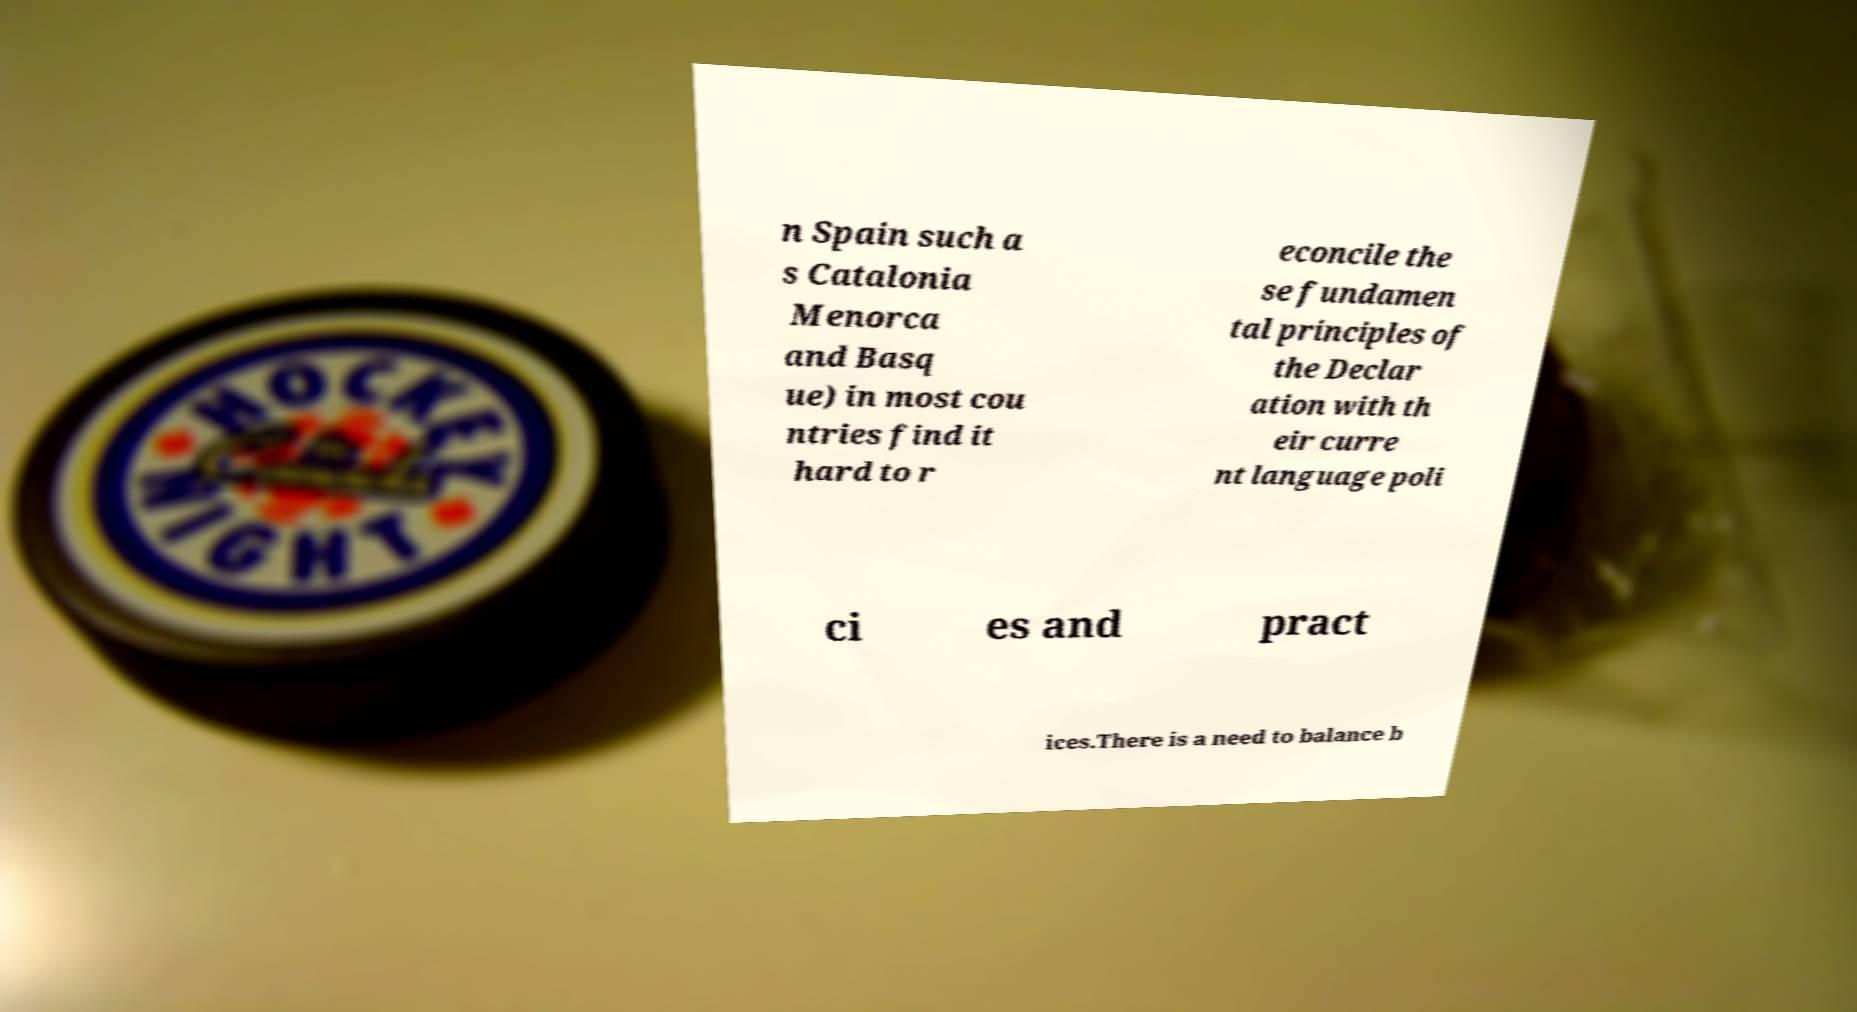Please read and relay the text visible in this image. What does it say? n Spain such a s Catalonia Menorca and Basq ue) in most cou ntries find it hard to r econcile the se fundamen tal principles of the Declar ation with th eir curre nt language poli ci es and pract ices.There is a need to balance b 